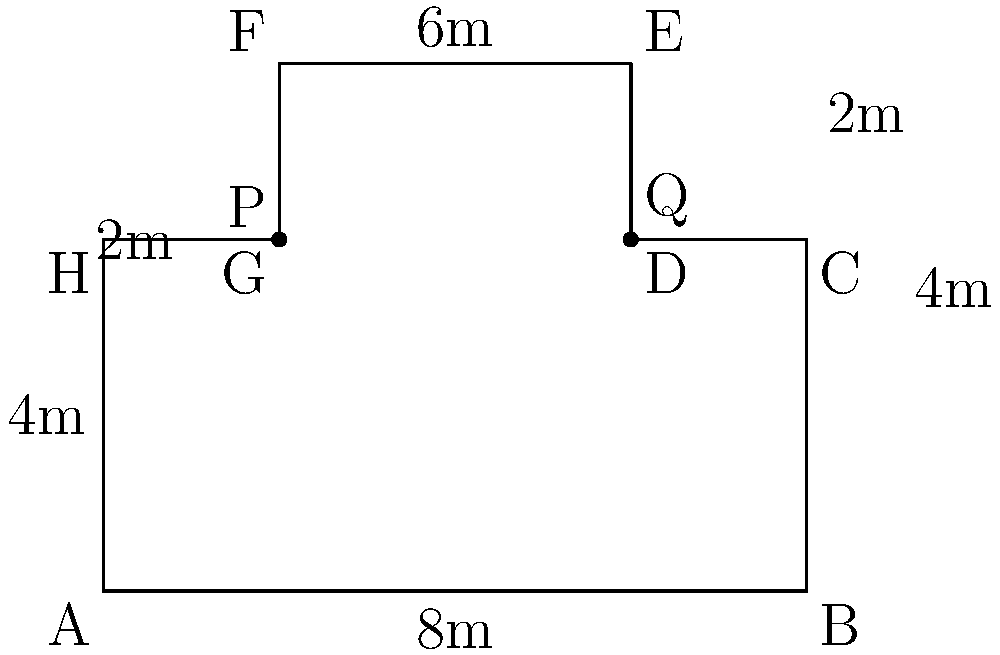As a local government news reporter, you're covering a story about a new public park in Manila. The park has an irregular shape, as shown in the diagram. To calculate its area accurately, you decide to divide it into geometric shapes. What is the total area of the park in square meters? Let's break down the park into simple geometric shapes:

1. Rectangle ABCH:
   Area = $8 \text{ m} \times 4 \text{ m} = 32 \text{ m}^2$

2. Rectangle DEFG:
   Area = $4 \text{ m} \times 2 \text{ m} = 8 \text{ m}^2$

3. Rectangle PQED:
   Area = $4 \text{ m} \times 2 \text{ m} = 8 \text{ m}^2$

To find the total area, we add these together:

$$\text{Total Area} = 32 \text{ m}^2 + 8 \text{ m}^2 + 8 \text{ m}^2 = 48 \text{ m}^2$$

Therefore, the total area of the park is 48 square meters.
Answer: 48 m² 